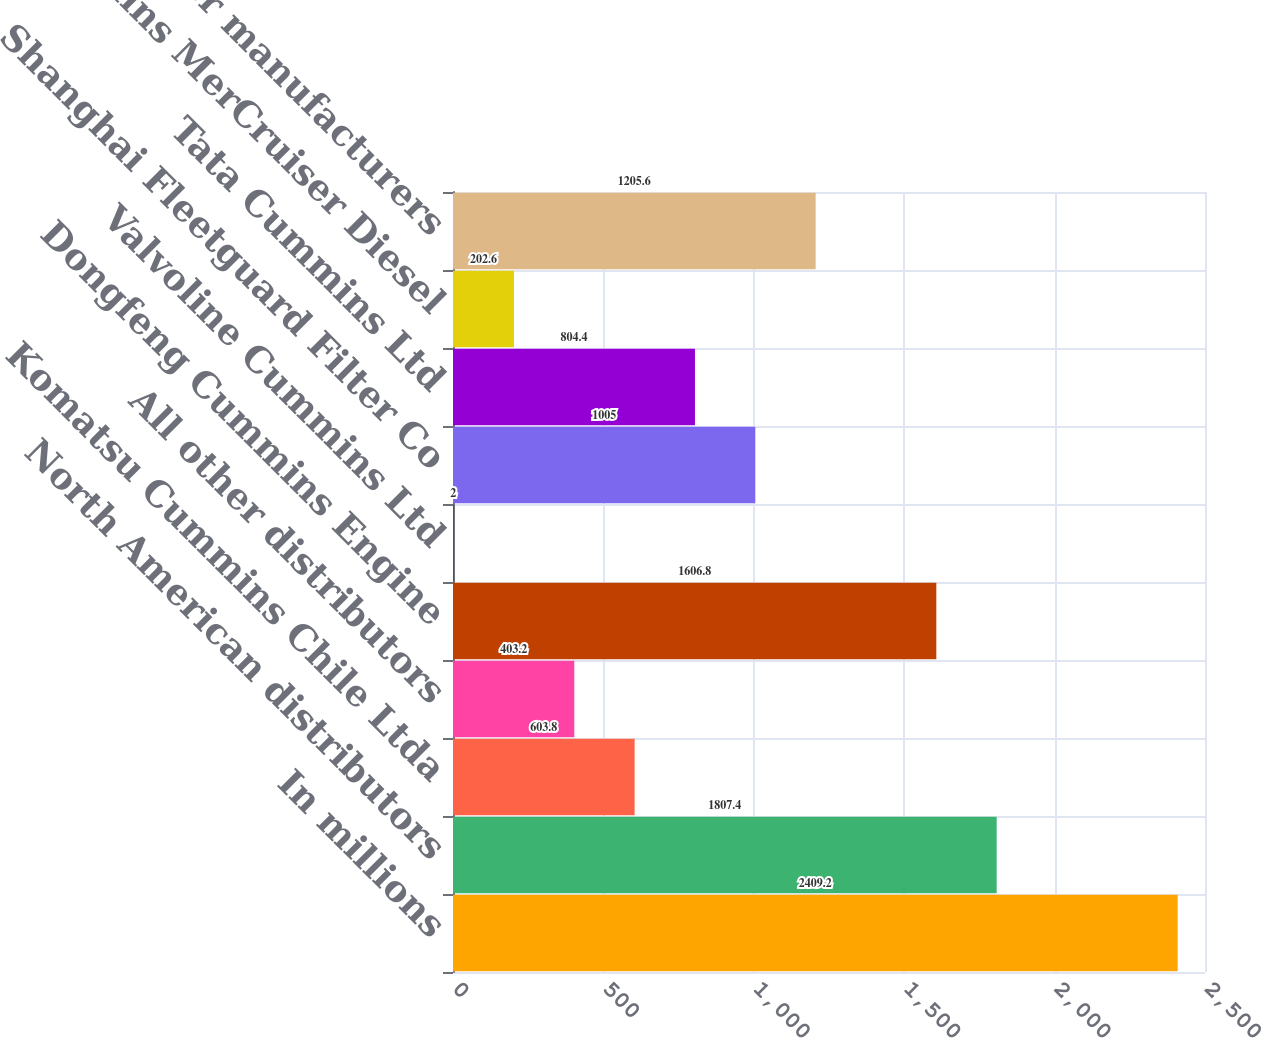Convert chart to OTSL. <chart><loc_0><loc_0><loc_500><loc_500><bar_chart><fcel>In millions<fcel>North American distributors<fcel>Komatsu Cummins Chile Ltda<fcel>All other distributors<fcel>Dongfeng Cummins Engine<fcel>Valvoline Cummins Ltd<fcel>Shanghai Fleetguard Filter Co<fcel>Tata Cummins Ltd<fcel>Cummins MerCruiser Diesel<fcel>All other manufacturers<nl><fcel>2409.2<fcel>1807.4<fcel>603.8<fcel>403.2<fcel>1606.8<fcel>2<fcel>1005<fcel>804.4<fcel>202.6<fcel>1205.6<nl></chart> 